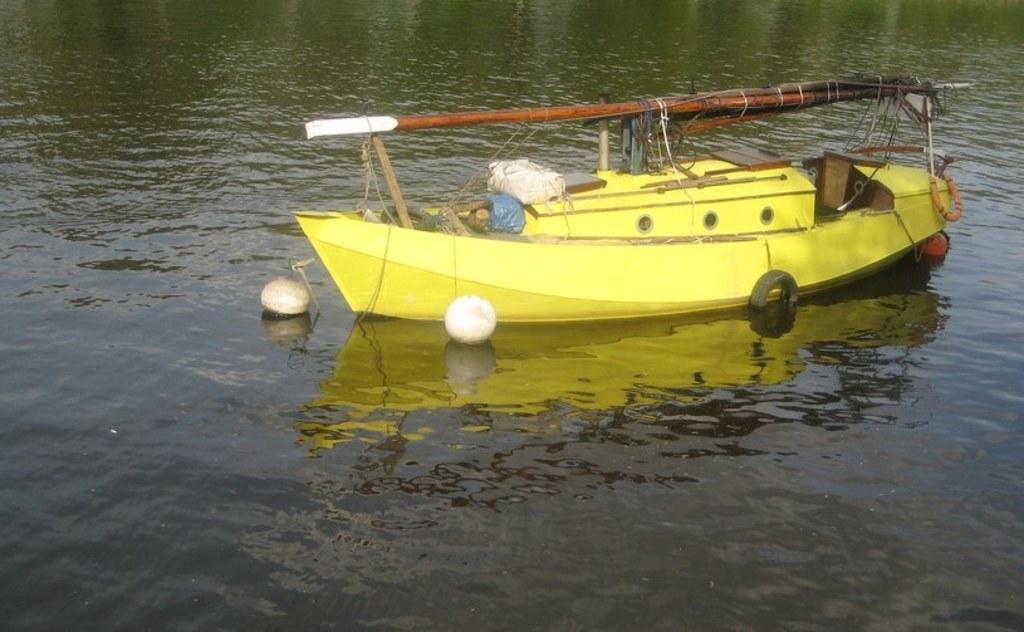Please provide a concise description of this image. In this image I can see a yellow colour boat on the water. I can also see two tubes and two white colour things near the boat. 